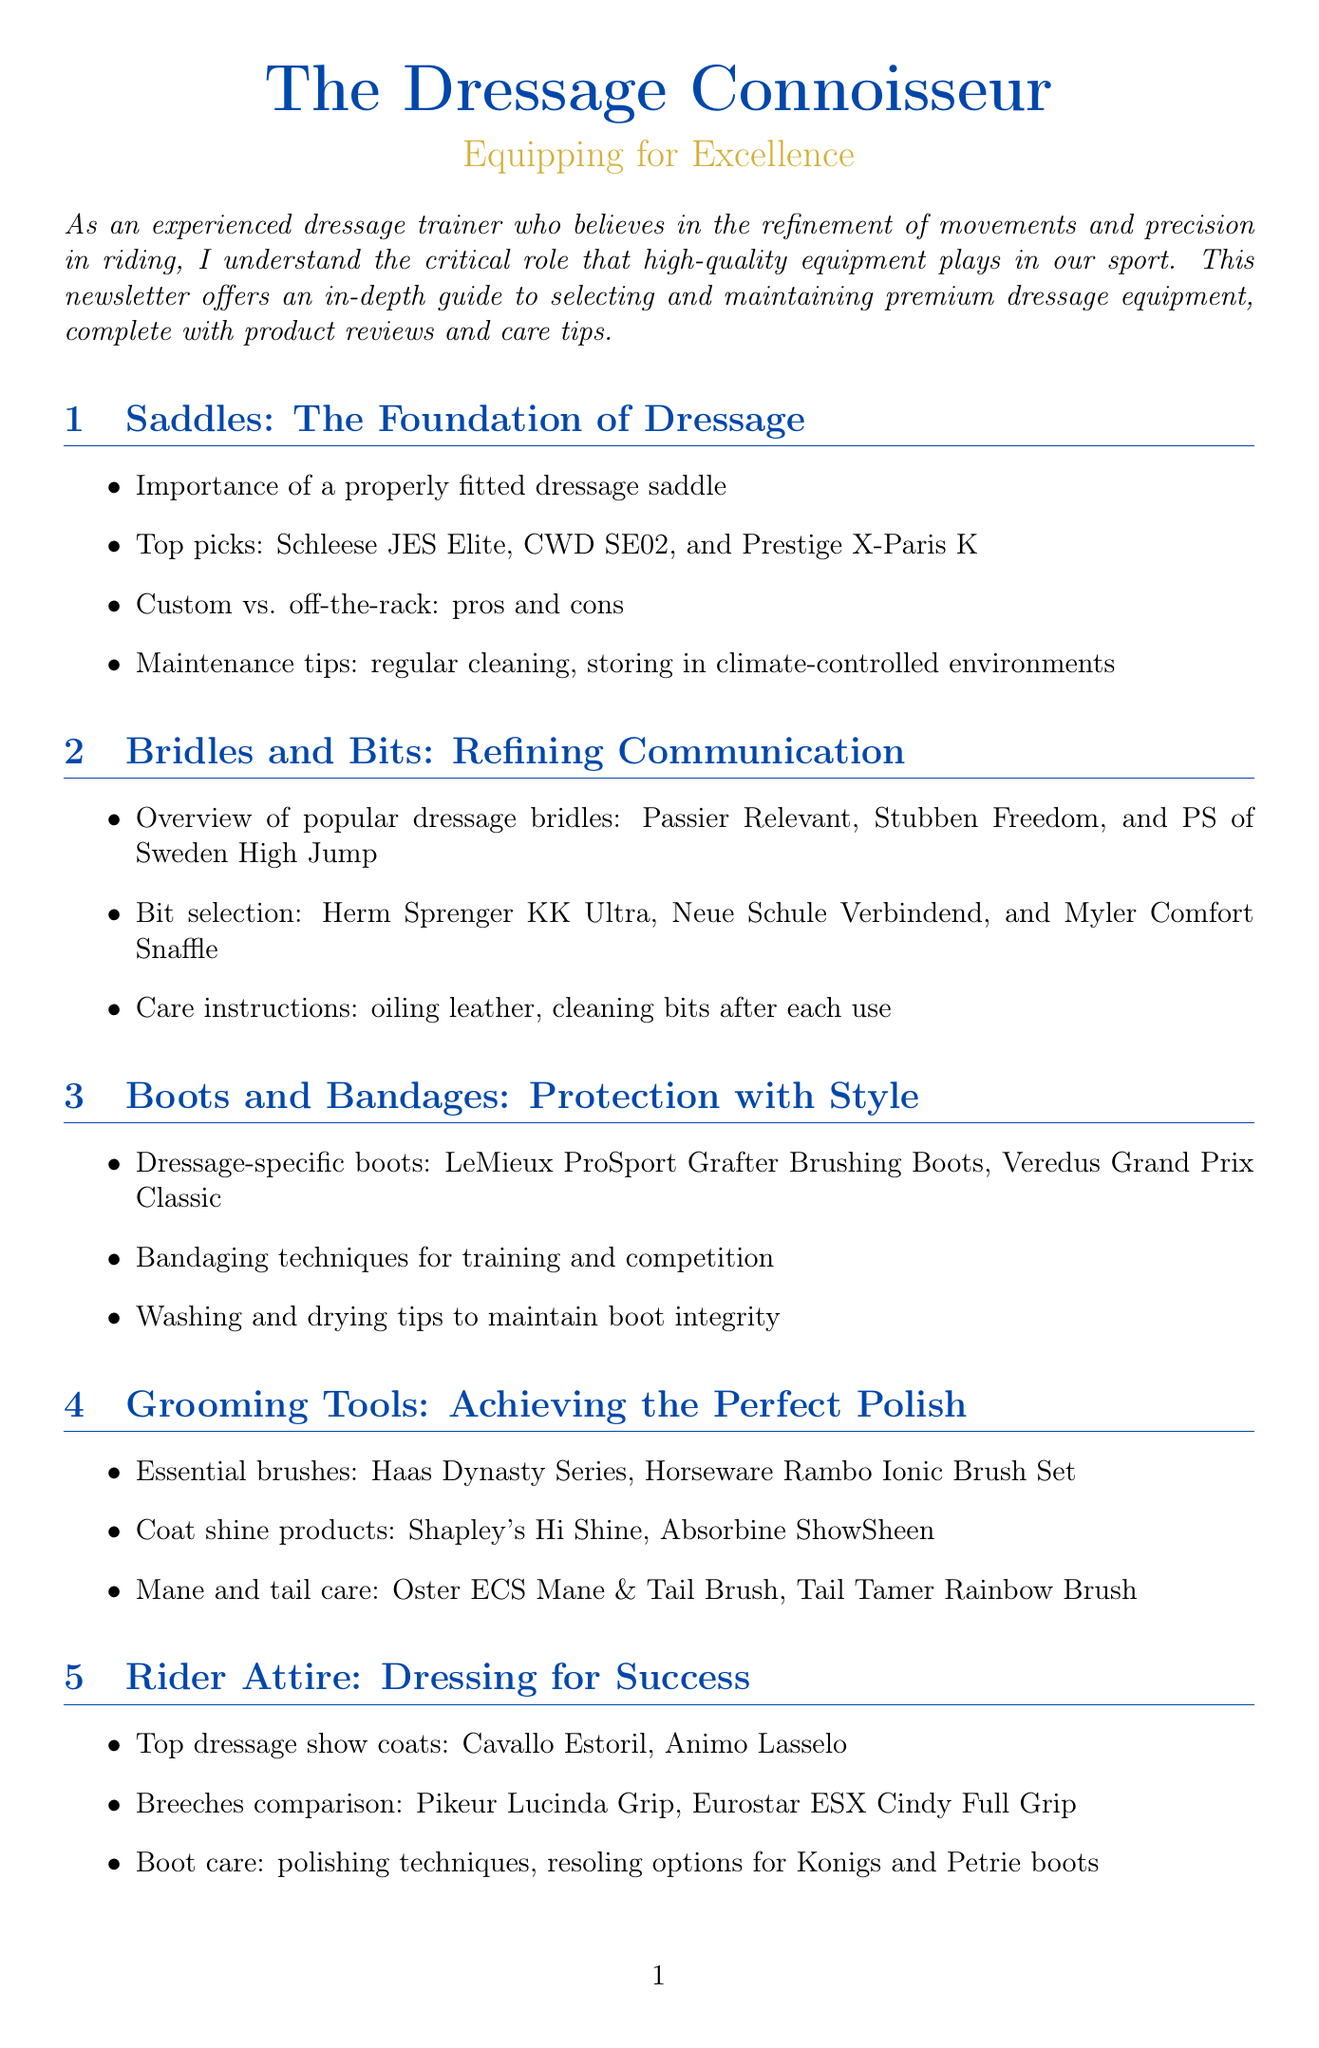What is the title of the newsletter? The title of the newsletter, as stated at the beginning, is a key identifier of the document.
Answer: The Dressage Connoisseur: Equipping for Excellence What is the rating of the Schleese JES Elite Dressage Saddle? The rating of the product review section gives insight into the quality of the saddle.
Answer: 4.8 Which saddle is listed as a top pick? Identifying the top pick provides information on recommended equipment for readers.
Answer: Schleese JES Elite What are the top dressage show coats mentioned? This question targets the section about rider attire, specifically looking for notable products.
Answer: Cavallo Estoril, Animo Lasselo How many steps are there in the care tip of the month? Counting the steps in the care tips section allows readers to gauge the level of commitment needed for maintenance.
Answer: 5 What is the location of the Adequan Global Dressage Festival? this question seeks specific event details relevant to dressage enthusiasts.
Answer: Wellington, Florida What is the name of a recommended grazing boot? This question addresses the equipment section relevant to the protection of the horse’s legs.
Answer: LeMieux ProSport Grafter Brushing Boots What product is suggested for coat shine? Identifying grooming products helps trainers maintain their horses' appearance effectively.
Answer: Shapley's Hi Shine What is a con of the Schleese JES Elite Dressage Saddle? This question provides insight into potential drawbacks, essential for informed decision-making.
Answer: Higher price point 